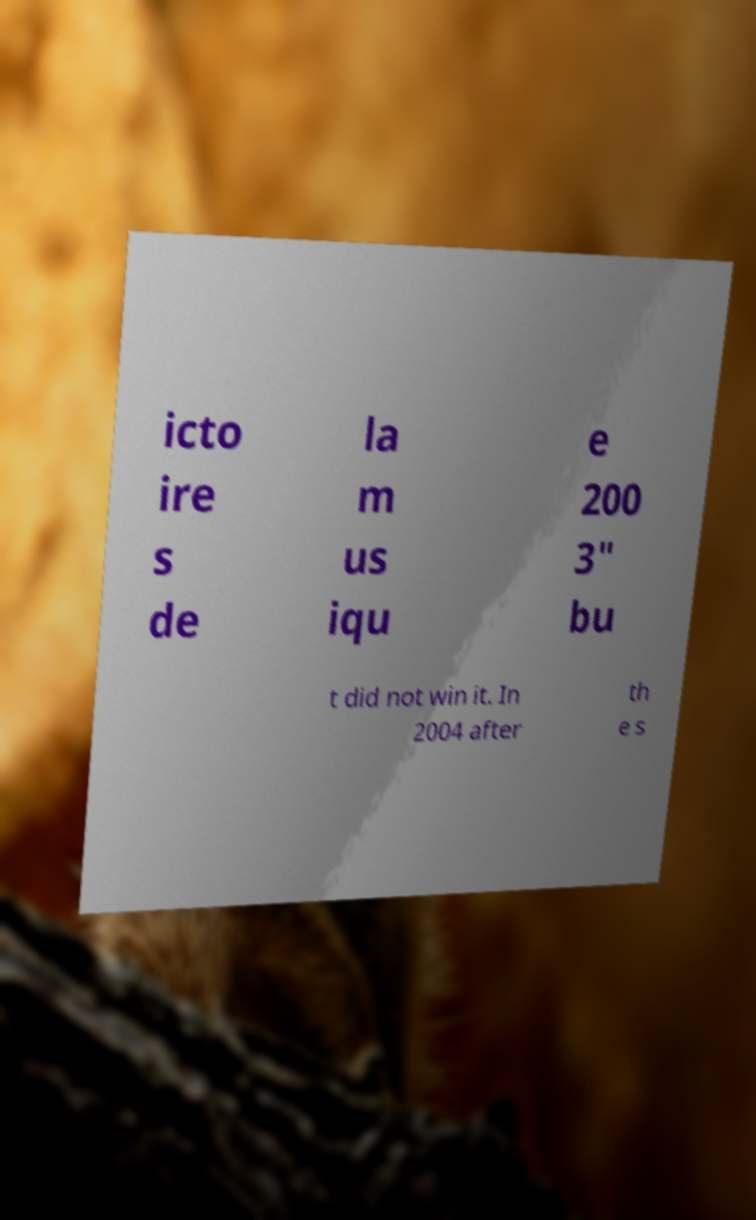Please identify and transcribe the text found in this image. icto ire s de la m us iqu e 200 3" bu t did not win it. In 2004 after th e s 